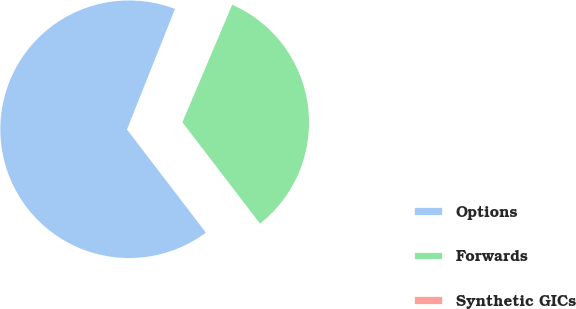Convert chart to OTSL. <chart><loc_0><loc_0><loc_500><loc_500><pie_chart><fcel>Options<fcel>Forwards<fcel>Synthetic GICs<nl><fcel>66.43%<fcel>33.22%<fcel>0.35%<nl></chart> 